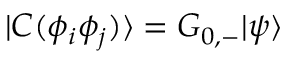<formula> <loc_0><loc_0><loc_500><loc_500>| C ( \phi _ { i } \phi _ { j } ) \rangle = G _ { 0 , - } | \psi \rangle</formula> 